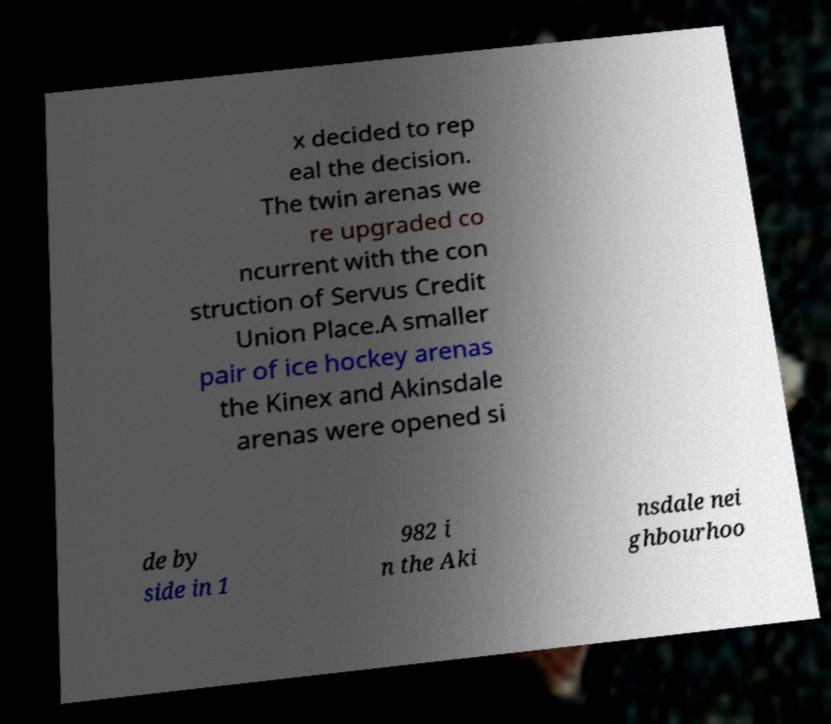What messages or text are displayed in this image? I need them in a readable, typed format. x decided to rep eal the decision. The twin arenas we re upgraded co ncurrent with the con struction of Servus Credit Union Place.A smaller pair of ice hockey arenas the Kinex and Akinsdale arenas were opened si de by side in 1 982 i n the Aki nsdale nei ghbourhoo 